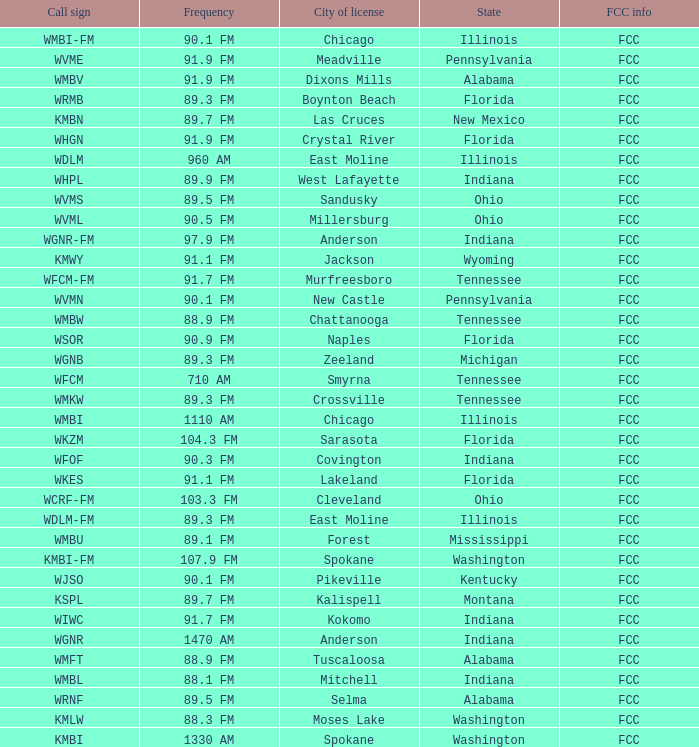I'm looking to parse the entire table for insights. Could you assist me with that? {'header': ['Call sign', 'Frequency', 'City of license', 'State', 'FCC info'], 'rows': [['WMBI-FM', '90.1 FM', 'Chicago', 'Illinois', 'FCC'], ['WVME', '91.9 FM', 'Meadville', 'Pennsylvania', 'FCC'], ['WMBV', '91.9 FM', 'Dixons Mills', 'Alabama', 'FCC'], ['WRMB', '89.3 FM', 'Boynton Beach', 'Florida', 'FCC'], ['KMBN', '89.7 FM', 'Las Cruces', 'New Mexico', 'FCC'], ['WHGN', '91.9 FM', 'Crystal River', 'Florida', 'FCC'], ['WDLM', '960 AM', 'East Moline', 'Illinois', 'FCC'], ['WHPL', '89.9 FM', 'West Lafayette', 'Indiana', 'FCC'], ['WVMS', '89.5 FM', 'Sandusky', 'Ohio', 'FCC'], ['WVML', '90.5 FM', 'Millersburg', 'Ohio', 'FCC'], ['WGNR-FM', '97.9 FM', 'Anderson', 'Indiana', 'FCC'], ['KMWY', '91.1 FM', 'Jackson', 'Wyoming', 'FCC'], ['WFCM-FM', '91.7 FM', 'Murfreesboro', 'Tennessee', 'FCC'], ['WVMN', '90.1 FM', 'New Castle', 'Pennsylvania', 'FCC'], ['WMBW', '88.9 FM', 'Chattanooga', 'Tennessee', 'FCC'], ['WSOR', '90.9 FM', 'Naples', 'Florida', 'FCC'], ['WGNB', '89.3 FM', 'Zeeland', 'Michigan', 'FCC'], ['WFCM', '710 AM', 'Smyrna', 'Tennessee', 'FCC'], ['WMKW', '89.3 FM', 'Crossville', 'Tennessee', 'FCC'], ['WMBI', '1110 AM', 'Chicago', 'Illinois', 'FCC'], ['WKZM', '104.3 FM', 'Sarasota', 'Florida', 'FCC'], ['WFOF', '90.3 FM', 'Covington', 'Indiana', 'FCC'], ['WKES', '91.1 FM', 'Lakeland', 'Florida', 'FCC'], ['WCRF-FM', '103.3 FM', 'Cleveland', 'Ohio', 'FCC'], ['WDLM-FM', '89.3 FM', 'East Moline', 'Illinois', 'FCC'], ['WMBU', '89.1 FM', 'Forest', 'Mississippi', 'FCC'], ['KMBI-FM', '107.9 FM', 'Spokane', 'Washington', 'FCC'], ['WJSO', '90.1 FM', 'Pikeville', 'Kentucky', 'FCC'], ['KSPL', '89.7 FM', 'Kalispell', 'Montana', 'FCC'], ['WIWC', '91.7 FM', 'Kokomo', 'Indiana', 'FCC'], ['WGNR', '1470 AM', 'Anderson', 'Indiana', 'FCC'], ['WMFT', '88.9 FM', 'Tuscaloosa', 'Alabama', 'FCC'], ['WMBL', '88.1 FM', 'Mitchell', 'Indiana', 'FCC'], ['WRNF', '89.5 FM', 'Selma', 'Alabama', 'FCC'], ['KMLW', '88.3 FM', 'Moses Lake', 'Washington', 'FCC'], ['KMBI', '1330 AM', 'Spokane', 'Washington', 'FCC']]} What city is 103.3 FM licensed in? Cleveland. 